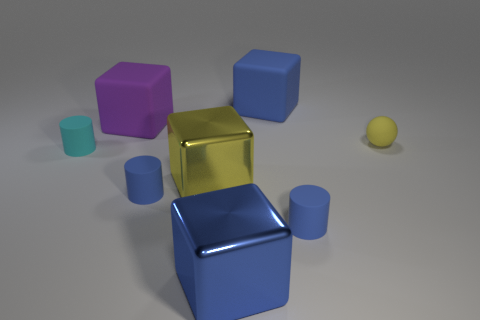What number of cyan things are either metal objects or cylinders?
Offer a very short reply. 1. There is a yellow object that is in front of the small rubber sphere; is it the same shape as the object that is left of the purple object?
Your answer should be compact. No. What number of other things are there of the same material as the tiny sphere
Make the answer very short. 5. Is there a big purple matte object behind the tiny blue cylinder that is left of the matte block that is right of the big purple block?
Offer a terse response. Yes. Do the tiny ball and the big purple object have the same material?
Keep it short and to the point. Yes. Are there any other things that are the same shape as the tiny yellow thing?
Make the answer very short. No. There is a small blue cylinder to the right of the large blue cube that is behind the cyan cylinder; what is its material?
Your answer should be very brief. Rubber. There is a object that is on the left side of the purple cube; what size is it?
Ensure brevity in your answer.  Small. What color is the small rubber thing that is right of the purple object and behind the yellow cube?
Make the answer very short. Yellow. There is a yellow thing that is on the left side of the rubber ball; is its size the same as the yellow matte thing?
Your answer should be compact. No. 